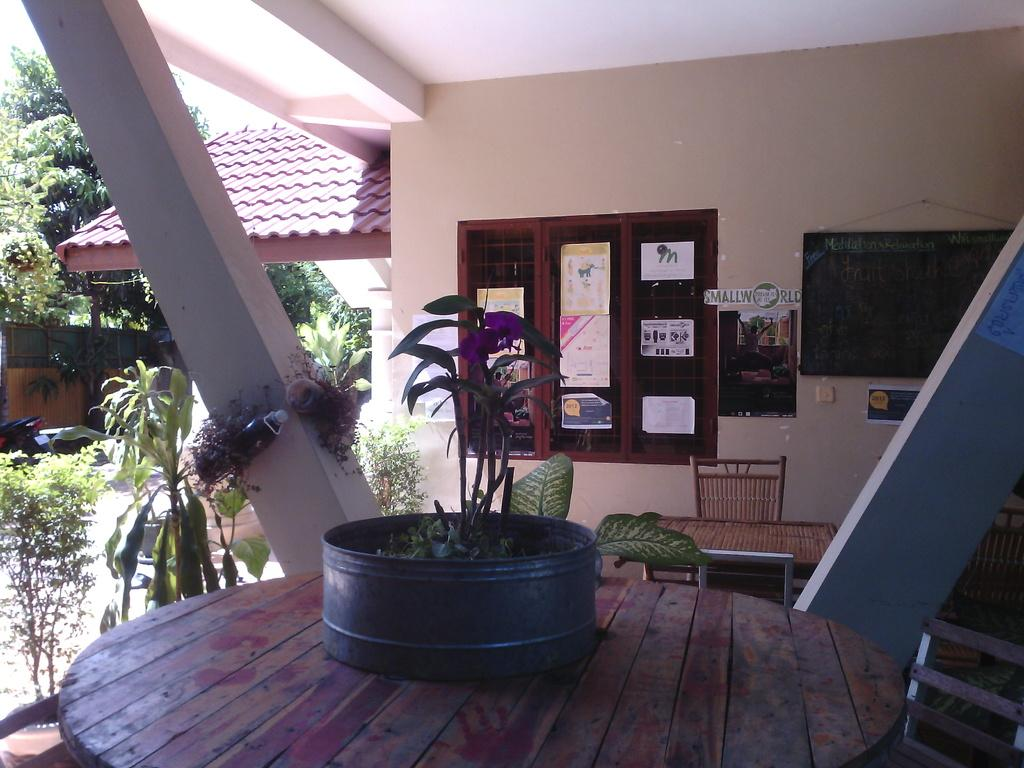What is the main object in the center of the image? There is a table in the center of the image. What is placed on the table? There is a plant pot on the table. What can be seen in the background of the image? There is a wall, a window, another table, a chair, a plant, a roof, sky, a tree, and a bike visible in the background of the image. What type of soup is being served by the team in the image? There is no team or soup present in the image. Who is the expert in the image? There is no expert or indication of expertise in the image. 